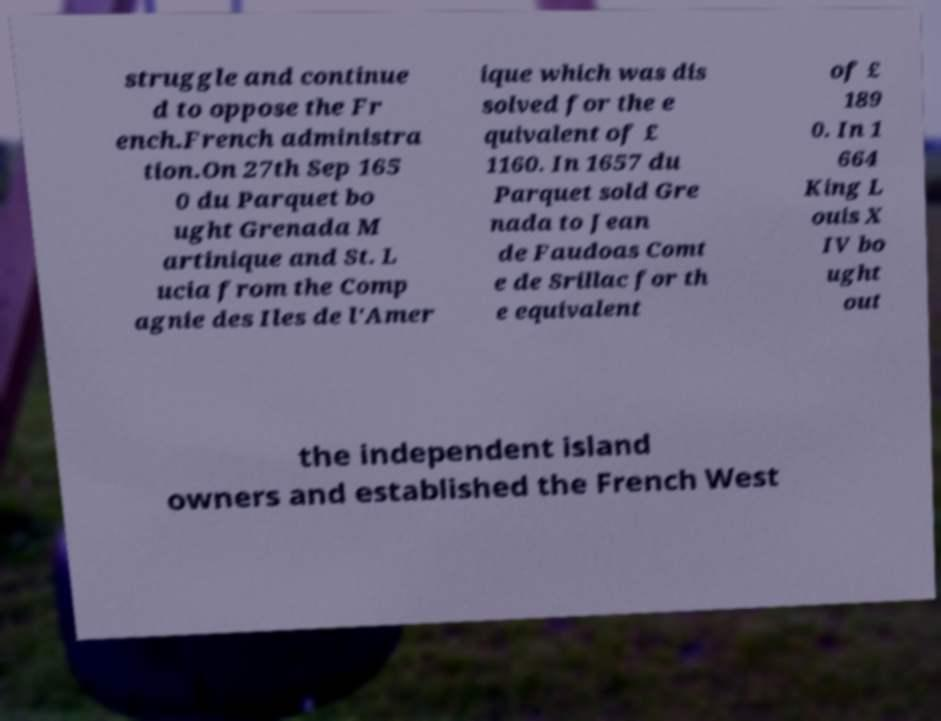I need the written content from this picture converted into text. Can you do that? struggle and continue d to oppose the Fr ench.French administra tion.On 27th Sep 165 0 du Parquet bo ught Grenada M artinique and St. L ucia from the Comp agnie des Iles de l'Amer ique which was dis solved for the e quivalent of £ 1160. In 1657 du Parquet sold Gre nada to Jean de Faudoas Comt e de Srillac for th e equivalent of £ 189 0. In 1 664 King L ouis X IV bo ught out the independent island owners and established the French West 